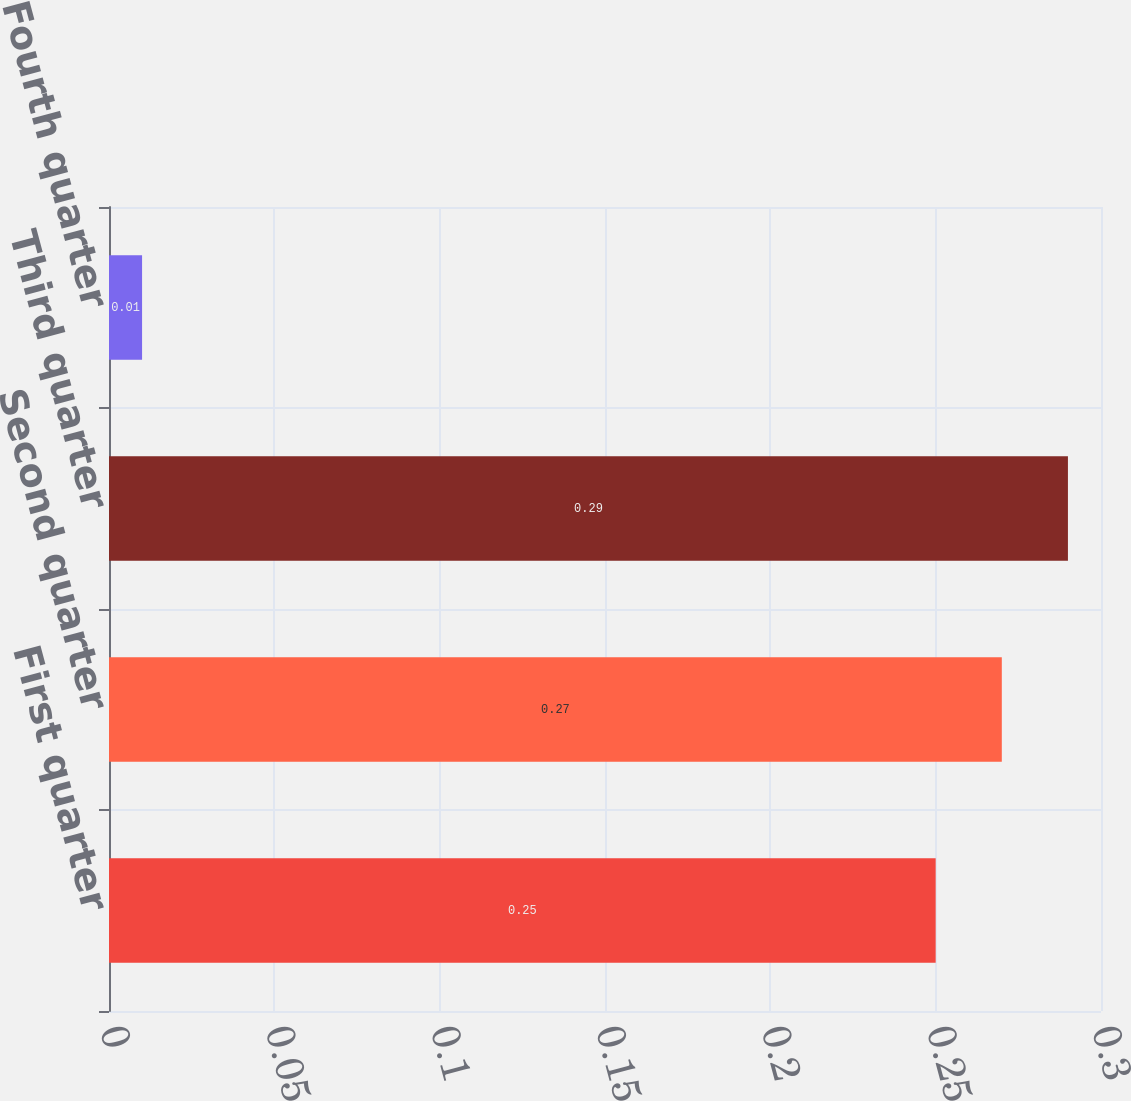<chart> <loc_0><loc_0><loc_500><loc_500><bar_chart><fcel>First quarter<fcel>Second quarter<fcel>Third quarter<fcel>Fourth quarter<nl><fcel>0.25<fcel>0.27<fcel>0.29<fcel>0.01<nl></chart> 